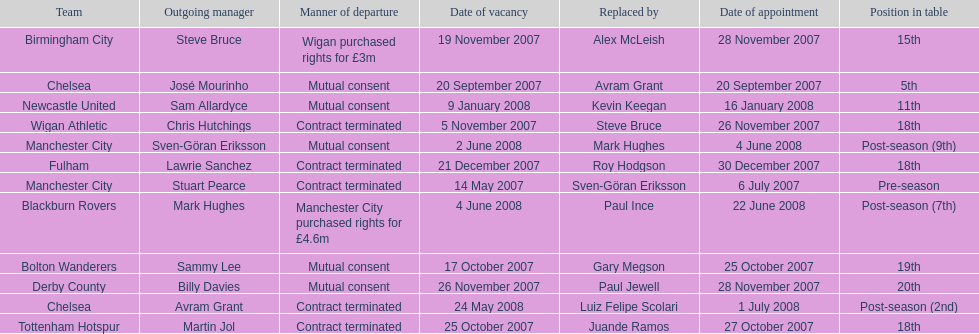Would you mind parsing the complete table? {'header': ['Team', 'Outgoing manager', 'Manner of departure', 'Date of vacancy', 'Replaced by', 'Date of appointment', 'Position in table'], 'rows': [['Birmingham City', 'Steve Bruce', 'Wigan purchased rights for £3m', '19 November 2007', 'Alex McLeish', '28 November 2007', '15th'], ['Chelsea', 'José Mourinho', 'Mutual consent', '20 September 2007', 'Avram Grant', '20 September 2007', '5th'], ['Newcastle United', 'Sam Allardyce', 'Mutual consent', '9 January 2008', 'Kevin Keegan', '16 January 2008', '11th'], ['Wigan Athletic', 'Chris Hutchings', 'Contract terminated', '5 November 2007', 'Steve Bruce', '26 November 2007', '18th'], ['Manchester City', 'Sven-Göran Eriksson', 'Mutual consent', '2 June 2008', 'Mark Hughes', '4 June 2008', 'Post-season (9th)'], ['Fulham', 'Lawrie Sanchez', 'Contract terminated', '21 December 2007', 'Roy Hodgson', '30 December 2007', '18th'], ['Manchester City', 'Stuart Pearce', 'Contract terminated', '14 May 2007', 'Sven-Göran Eriksson', '6 July 2007', 'Pre-season'], ['Blackburn Rovers', 'Mark Hughes', 'Manchester City purchased rights for £4.6m', '4 June 2008', 'Paul Ince', '22 June 2008', 'Post-season (7th)'], ['Bolton Wanderers', 'Sammy Lee', 'Mutual consent', '17 October 2007', 'Gary Megson', '25 October 2007', '19th'], ['Derby County', 'Billy Davies', 'Mutual consent', '26 November 2007', 'Paul Jewell', '28 November 2007', '20th'], ['Chelsea', 'Avram Grant', 'Contract terminated', '24 May 2008', 'Luiz Felipe Scolari', '1 July 2008', 'Post-season (2nd)'], ['Tottenham Hotspur', 'Martin Jol', 'Contract terminated', '25 October 2007', 'Juande Ramos', '27 October 2007', '18th']]} Who was manager of manchester city after stuart pearce left in 2007? Sven-Göran Eriksson. 